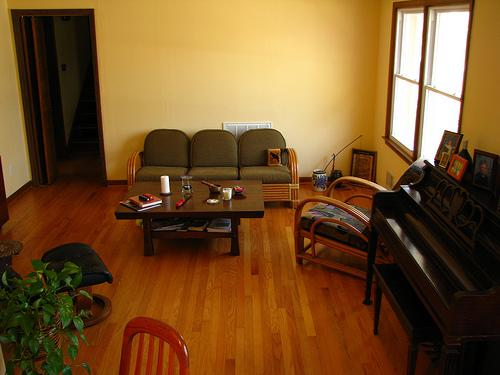Question: where is the picture taken?
Choices:
A. Living room.
B. Dining room.
C. Bedroom.
D. Kitchen.
Answer with the letter. Answer: A Question: where is the air vent?
Choices:
A. On the ceiling.
B. On the floor.
C. Behind couch.
D. Over the stove.
Answer with the letter. Answer: C 